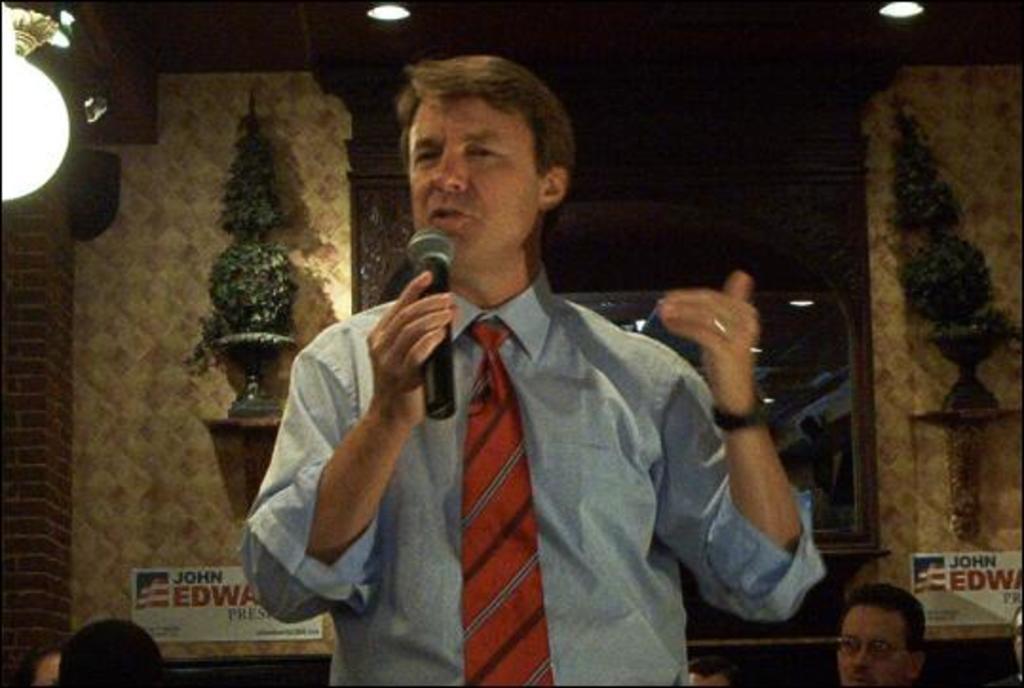Describe this image in one or two sentences. There is a person holding mic and talking. In the back there is a wall with some stand. On that there are some decorative items. On the ceiling there are lights. 